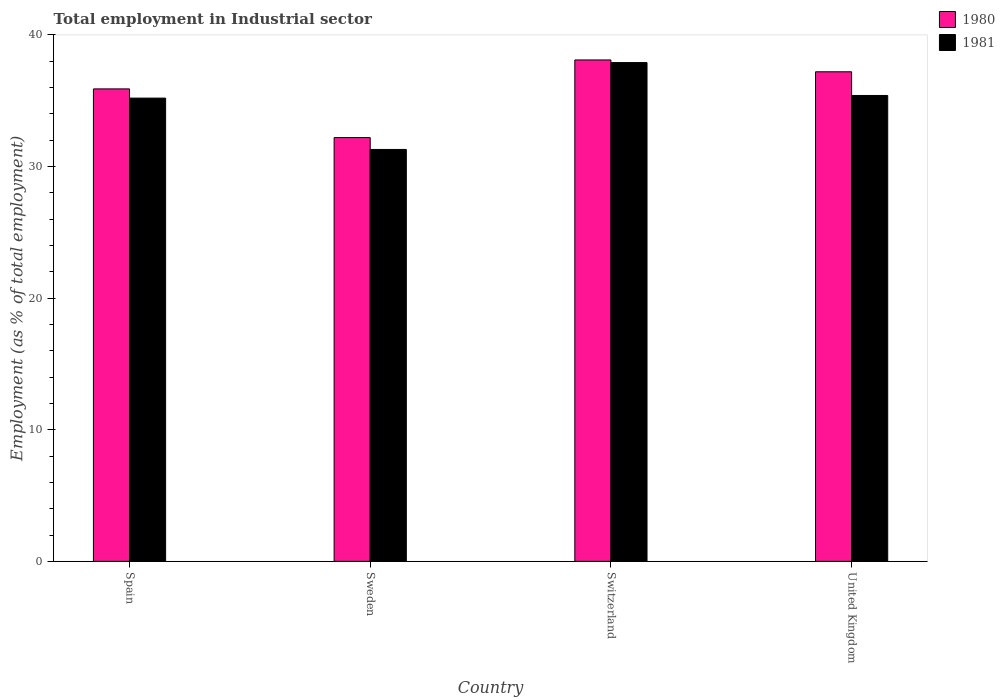Are the number of bars per tick equal to the number of legend labels?
Your answer should be compact. Yes. Are the number of bars on each tick of the X-axis equal?
Offer a very short reply. Yes. How many bars are there on the 4th tick from the left?
Provide a short and direct response. 2. How many bars are there on the 4th tick from the right?
Offer a very short reply. 2. What is the label of the 4th group of bars from the left?
Your response must be concise. United Kingdom. In how many cases, is the number of bars for a given country not equal to the number of legend labels?
Provide a short and direct response. 0. What is the employment in industrial sector in 1980 in Sweden?
Your answer should be very brief. 32.2. Across all countries, what is the maximum employment in industrial sector in 1981?
Your answer should be compact. 37.9. Across all countries, what is the minimum employment in industrial sector in 1980?
Keep it short and to the point. 32.2. In which country was the employment in industrial sector in 1981 maximum?
Provide a succinct answer. Switzerland. What is the total employment in industrial sector in 1980 in the graph?
Give a very brief answer. 143.4. What is the difference between the employment in industrial sector in 1981 in Spain and that in Switzerland?
Your response must be concise. -2.7. What is the difference between the employment in industrial sector in 1981 in Sweden and the employment in industrial sector in 1980 in Switzerland?
Offer a terse response. -6.8. What is the average employment in industrial sector in 1980 per country?
Provide a succinct answer. 35.85. What is the difference between the employment in industrial sector of/in 1981 and employment in industrial sector of/in 1980 in United Kingdom?
Your answer should be compact. -1.8. In how many countries, is the employment in industrial sector in 1980 greater than 36 %?
Make the answer very short. 2. What is the ratio of the employment in industrial sector in 1980 in Spain to that in Switzerland?
Provide a succinct answer. 0.94. Is the employment in industrial sector in 1980 in Switzerland less than that in United Kingdom?
Your response must be concise. No. What is the difference between the highest and the second highest employment in industrial sector in 1981?
Give a very brief answer. -0.2. What is the difference between the highest and the lowest employment in industrial sector in 1980?
Give a very brief answer. 5.9. Is the sum of the employment in industrial sector in 1980 in Switzerland and United Kingdom greater than the maximum employment in industrial sector in 1981 across all countries?
Make the answer very short. Yes. What does the 2nd bar from the left in United Kingdom represents?
Your response must be concise. 1981. What does the 2nd bar from the right in Switzerland represents?
Your response must be concise. 1980. How many bars are there?
Provide a short and direct response. 8. How many countries are there in the graph?
Your answer should be compact. 4. What is the difference between two consecutive major ticks on the Y-axis?
Your answer should be very brief. 10. What is the title of the graph?
Offer a very short reply. Total employment in Industrial sector. Does "1970" appear as one of the legend labels in the graph?
Keep it short and to the point. No. What is the label or title of the Y-axis?
Ensure brevity in your answer.  Employment (as % of total employment). What is the Employment (as % of total employment) of 1980 in Spain?
Your answer should be very brief. 35.9. What is the Employment (as % of total employment) of 1981 in Spain?
Give a very brief answer. 35.2. What is the Employment (as % of total employment) of 1980 in Sweden?
Provide a short and direct response. 32.2. What is the Employment (as % of total employment) in 1981 in Sweden?
Make the answer very short. 31.3. What is the Employment (as % of total employment) of 1980 in Switzerland?
Give a very brief answer. 38.1. What is the Employment (as % of total employment) in 1981 in Switzerland?
Your response must be concise. 37.9. What is the Employment (as % of total employment) in 1980 in United Kingdom?
Offer a very short reply. 37.2. What is the Employment (as % of total employment) of 1981 in United Kingdom?
Provide a succinct answer. 35.4. Across all countries, what is the maximum Employment (as % of total employment) of 1980?
Provide a succinct answer. 38.1. Across all countries, what is the maximum Employment (as % of total employment) of 1981?
Provide a short and direct response. 37.9. Across all countries, what is the minimum Employment (as % of total employment) in 1980?
Offer a very short reply. 32.2. Across all countries, what is the minimum Employment (as % of total employment) in 1981?
Offer a very short reply. 31.3. What is the total Employment (as % of total employment) of 1980 in the graph?
Give a very brief answer. 143.4. What is the total Employment (as % of total employment) of 1981 in the graph?
Provide a succinct answer. 139.8. What is the difference between the Employment (as % of total employment) in 1981 in Spain and that in Switzerland?
Your response must be concise. -2.7. What is the difference between the Employment (as % of total employment) in 1980 in Sweden and that in Switzerland?
Your answer should be very brief. -5.9. What is the difference between the Employment (as % of total employment) in 1981 in Sweden and that in Switzerland?
Offer a terse response. -6.6. What is the difference between the Employment (as % of total employment) of 1980 in Sweden and that in United Kingdom?
Give a very brief answer. -5. What is the difference between the Employment (as % of total employment) in 1981 in Sweden and that in United Kingdom?
Your answer should be compact. -4.1. What is the difference between the Employment (as % of total employment) in 1981 in Switzerland and that in United Kingdom?
Your answer should be compact. 2.5. What is the difference between the Employment (as % of total employment) in 1980 in Sweden and the Employment (as % of total employment) in 1981 in United Kingdom?
Your answer should be very brief. -3.2. What is the difference between the Employment (as % of total employment) of 1980 in Switzerland and the Employment (as % of total employment) of 1981 in United Kingdom?
Ensure brevity in your answer.  2.7. What is the average Employment (as % of total employment) of 1980 per country?
Offer a very short reply. 35.85. What is the average Employment (as % of total employment) in 1981 per country?
Provide a short and direct response. 34.95. What is the difference between the Employment (as % of total employment) in 1980 and Employment (as % of total employment) in 1981 in Spain?
Your answer should be compact. 0.7. What is the difference between the Employment (as % of total employment) in 1980 and Employment (as % of total employment) in 1981 in Switzerland?
Offer a terse response. 0.2. What is the difference between the Employment (as % of total employment) of 1980 and Employment (as % of total employment) of 1981 in United Kingdom?
Your response must be concise. 1.8. What is the ratio of the Employment (as % of total employment) of 1980 in Spain to that in Sweden?
Your answer should be compact. 1.11. What is the ratio of the Employment (as % of total employment) of 1981 in Spain to that in Sweden?
Provide a short and direct response. 1.12. What is the ratio of the Employment (as % of total employment) of 1980 in Spain to that in Switzerland?
Give a very brief answer. 0.94. What is the ratio of the Employment (as % of total employment) in 1981 in Spain to that in Switzerland?
Offer a very short reply. 0.93. What is the ratio of the Employment (as % of total employment) of 1980 in Spain to that in United Kingdom?
Ensure brevity in your answer.  0.97. What is the ratio of the Employment (as % of total employment) of 1980 in Sweden to that in Switzerland?
Offer a terse response. 0.85. What is the ratio of the Employment (as % of total employment) in 1981 in Sweden to that in Switzerland?
Keep it short and to the point. 0.83. What is the ratio of the Employment (as % of total employment) of 1980 in Sweden to that in United Kingdom?
Make the answer very short. 0.87. What is the ratio of the Employment (as % of total employment) in 1981 in Sweden to that in United Kingdom?
Provide a short and direct response. 0.88. What is the ratio of the Employment (as % of total employment) of 1980 in Switzerland to that in United Kingdom?
Keep it short and to the point. 1.02. What is the ratio of the Employment (as % of total employment) of 1981 in Switzerland to that in United Kingdom?
Your response must be concise. 1.07. 